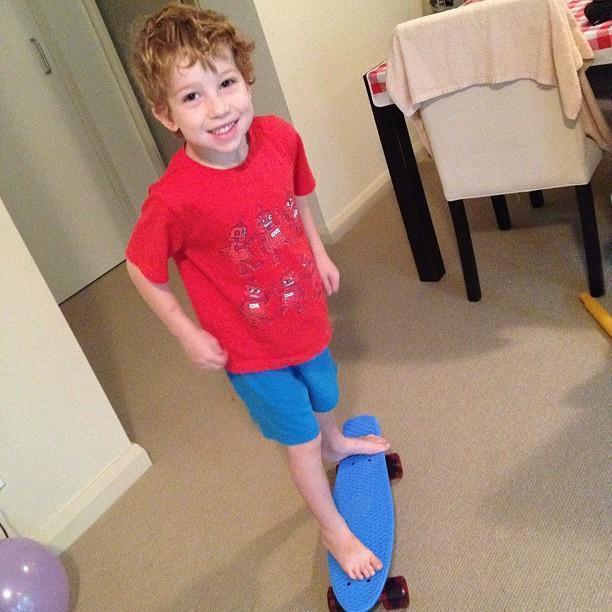The color of the boy's outfit matches the colors of the costume of what super hero?
Select the accurate answer and provide explanation: 'Answer: answer
Rationale: rationale.'
Options: Batman, spider man, wolverine, iron man. Answer: spider man.
Rationale: Spider man is known for red. 